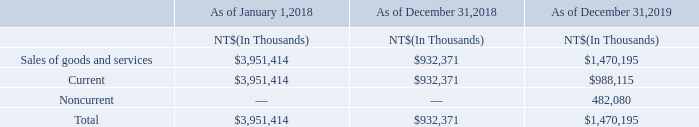The movement of contract liabilities is mainly caused by the timing difference of the satisfaction of a performance of obligation and the consideration received from customers.
The Company recognized NT$3,815 million and NT$616 million, respectively, in revenues from the contract liabilities balance at the beginning of the period as performance obligations were satisfied for the years ended December 31, 2018 and 2019.
What causes the  movement of contract liabilities? Mainly caused by the timing difference of the satisfaction of a performance of obligation and the consideration received from customers. What was the revenue recorded from the contract liabilities balance at the beginning of the period for the years ended December 31, 2018? Nt$3,815 million. What was the revenue recorded from the contract liabilities balance at the beginning of the period for the years ended December 31, 2019? Nt$616 million. What are the average Sales of goods and services for December 31, 2018 to 2019?
Answer scale should be: thousand. (932,371+1,470,195) / 2
Answer: 1201283. What is the increase/ (decrease) in Sales of goods and services for December 31, 2018 to 2019?
Answer scale should be: thousand. 1,470,195-932,371
Answer: 537824. What is the increase/ (decrease) in Sales of goods and services for January 1, 2018 to December 31, 2018?
Answer scale should be: thousand. 932,371-3,951,414
Answer: -3019043. 